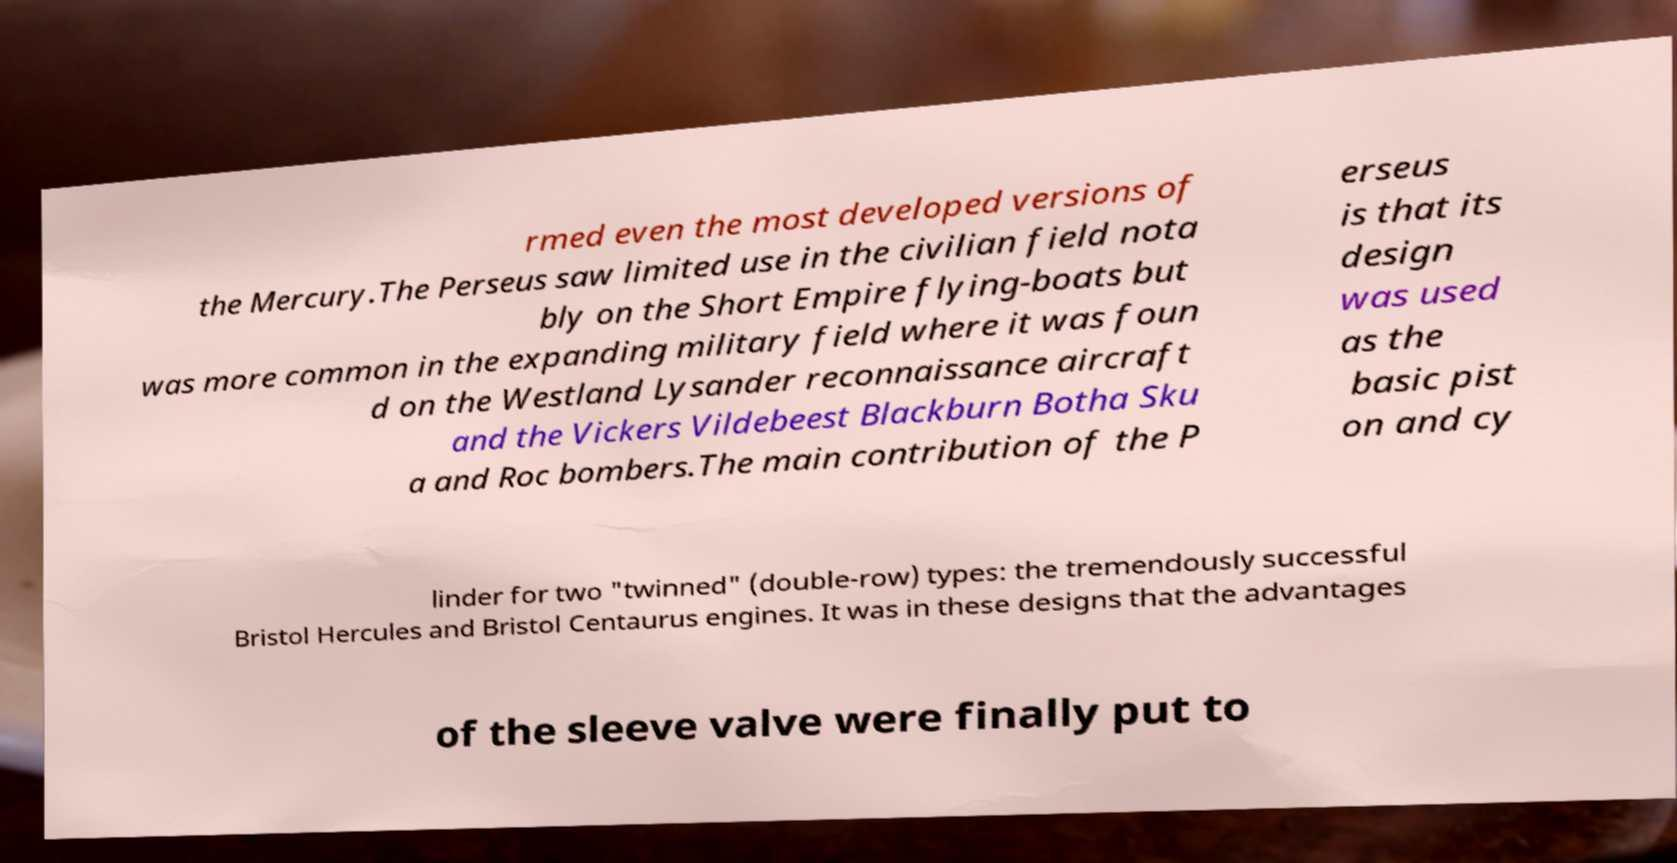Could you assist in decoding the text presented in this image and type it out clearly? rmed even the most developed versions of the Mercury.The Perseus saw limited use in the civilian field nota bly on the Short Empire flying-boats but was more common in the expanding military field where it was foun d on the Westland Lysander reconnaissance aircraft and the Vickers Vildebeest Blackburn Botha Sku a and Roc bombers.The main contribution of the P erseus is that its design was used as the basic pist on and cy linder for two "twinned" (double-row) types: the tremendously successful Bristol Hercules and Bristol Centaurus engines. It was in these designs that the advantages of the sleeve valve were finally put to 